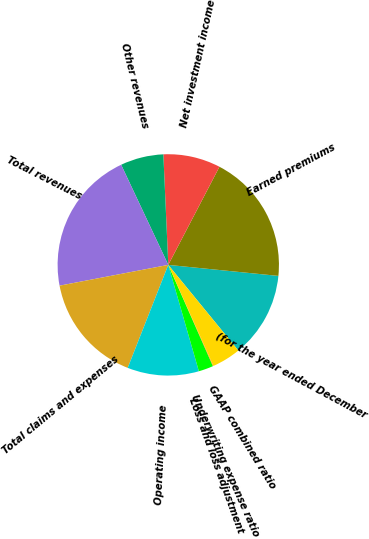Convert chart to OTSL. <chart><loc_0><loc_0><loc_500><loc_500><pie_chart><fcel>(for the year ended December<fcel>Earned premiums<fcel>Net investment income<fcel>Other revenues<fcel>Total revenues<fcel>Total claims and expenses<fcel>Operating income<fcel>Loss and loss adjustment<fcel>Underwriting expense ratio<fcel>GAAP combined ratio<nl><fcel>12.5%<fcel>18.93%<fcel>8.36%<fcel>6.29%<fcel>21.0%<fcel>16.02%<fcel>10.43%<fcel>2.15%<fcel>0.08%<fcel>4.22%<nl></chart> 